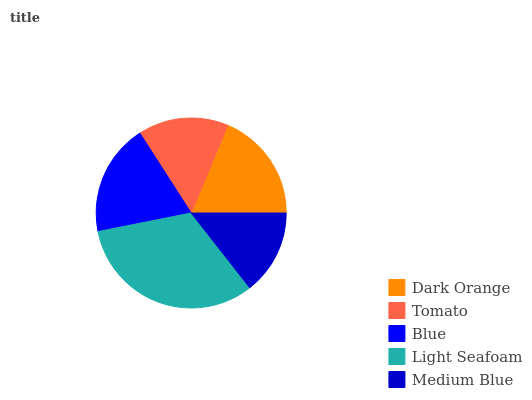Is Medium Blue the minimum?
Answer yes or no. Yes. Is Light Seafoam the maximum?
Answer yes or no. Yes. Is Tomato the minimum?
Answer yes or no. No. Is Tomato the maximum?
Answer yes or no. No. Is Dark Orange greater than Tomato?
Answer yes or no. Yes. Is Tomato less than Dark Orange?
Answer yes or no. Yes. Is Tomato greater than Dark Orange?
Answer yes or no. No. Is Dark Orange less than Tomato?
Answer yes or no. No. Is Dark Orange the high median?
Answer yes or no. Yes. Is Dark Orange the low median?
Answer yes or no. Yes. Is Tomato the high median?
Answer yes or no. No. Is Medium Blue the low median?
Answer yes or no. No. 